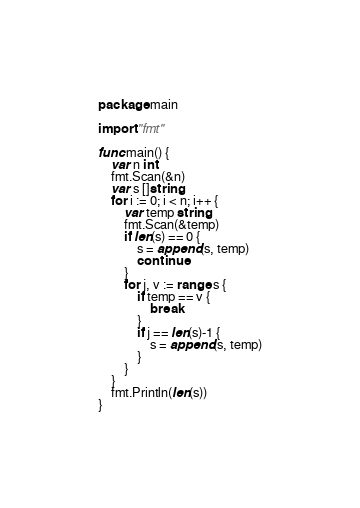<code> <loc_0><loc_0><loc_500><loc_500><_Go_>package main

import "fmt"

func main() {
	var n int
	fmt.Scan(&n)
	var s []string
	for i := 0; i < n; i++ {
		var temp string
		fmt.Scan(&temp)
		if len(s) == 0 {
			s = append(s, temp)
			continue
		}
		for j, v := range s {
			if temp == v {
				break
			}
			if j == len(s)-1 {
				s = append(s, temp)
			}
		}
	}
	fmt.Println(len(s))
}</code> 